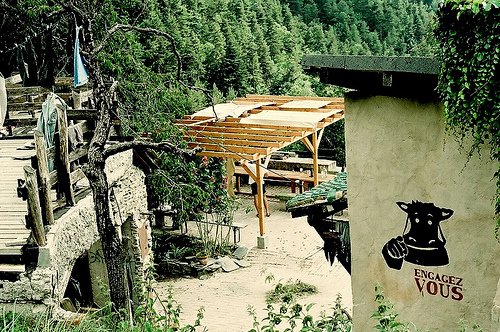<image>
Can you confirm if the cow is to the right of the wall? No. The cow is not to the right of the wall. The horizontal positioning shows a different relationship. 